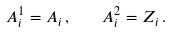<formula> <loc_0><loc_0><loc_500><loc_500>A ^ { 1 } _ { i } = A _ { i } \, , \quad A ^ { 2 } _ { i } = Z _ { i } \, .</formula> 